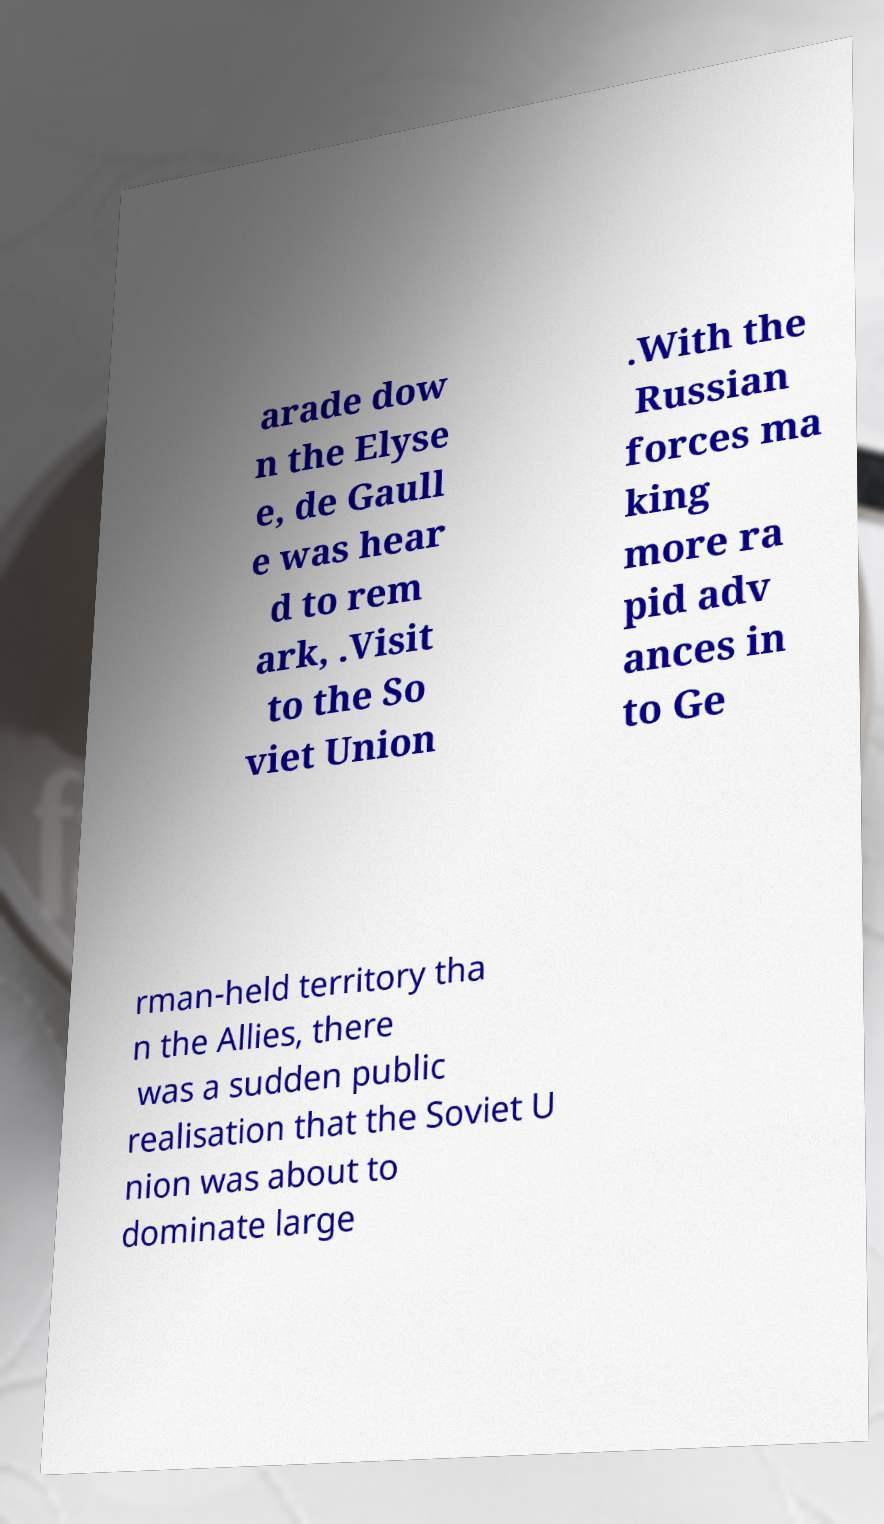I need the written content from this picture converted into text. Can you do that? arade dow n the Elyse e, de Gaull e was hear d to rem ark, .Visit to the So viet Union .With the Russian forces ma king more ra pid adv ances in to Ge rman-held territory tha n the Allies, there was a sudden public realisation that the Soviet U nion was about to dominate large 